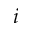Convert formula to latex. <formula><loc_0><loc_0><loc_500><loc_500>i</formula> 